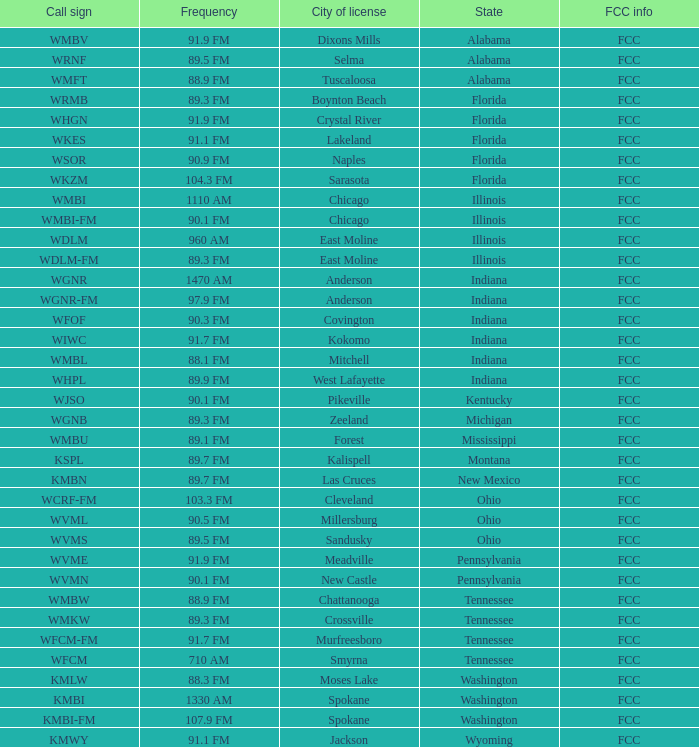What is the periodicity of the radio station in indiana possessing a call sign wgnr? 1470 AM. 